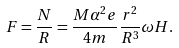Convert formula to latex. <formula><loc_0><loc_0><loc_500><loc_500>F = \frac { N } { R } = \frac { M \alpha ^ { 2 } e } { 4 m } \frac { r ^ { 2 } } { R ^ { 3 } } \omega H .</formula> 